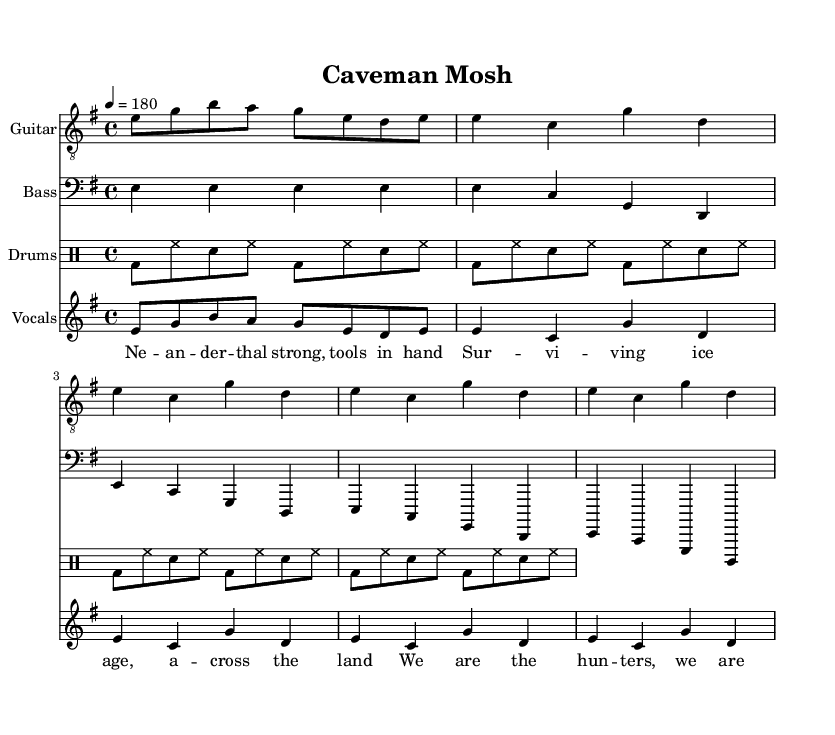What is the key signature of this music? The key signature is E minor, which contains one sharp (F#). This is indicated at the beginning of the staff where the sharps are placed.
Answer: E minor What is the time signature of this piece? The time signature is 4/4, shown directly after the key signature at the start of the music. This indicates four beats per measure.
Answer: 4/4 What is the tempo marking of the piece? The tempo marking is 180, which indicates that there are 180 beats per minute. This is explicitly written as "4 = 180" in the score.
Answer: 180 How many measures are in the verse section? The verse section consists of 4 measures as inferred from the guitar and bass parts; each part has two repetitions of the 2-measure phrase.
Answer: 4 measures What is the vocal theme of the chorus? The vocal theme of the chorus refers to the words “We are the hunters, we are the makers,” indicating a focus on survival and creation in the context of Neanderthal life, which is central to the lyrics.
Answer: Survival and creation How many times is the basic punk beat performed? The basic punk beat is performed a total of 8 times throughout the drum section, synchronized with the other instrumental parts.
Answer: 8 times What instruments are included in the score? The score includes Guitar, Bass, and Drums; each is represented by a separate staff and labeled clearly at the start of each staff.
Answer: Guitar, Bass, Drums 